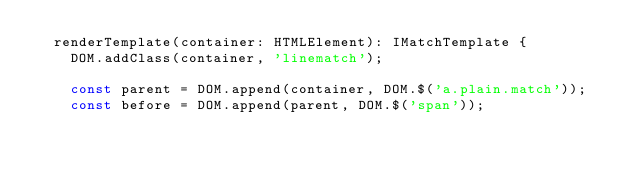Convert code to text. <code><loc_0><loc_0><loc_500><loc_500><_TypeScript_>	renderTemplate(container: HTMLElement): IMatchTemplate {
		DOM.addClass(container, 'linematch');

		const parent = DOM.append(container, DOM.$('a.plain.match'));
		const before = DOM.append(parent, DOM.$('span'));</code> 